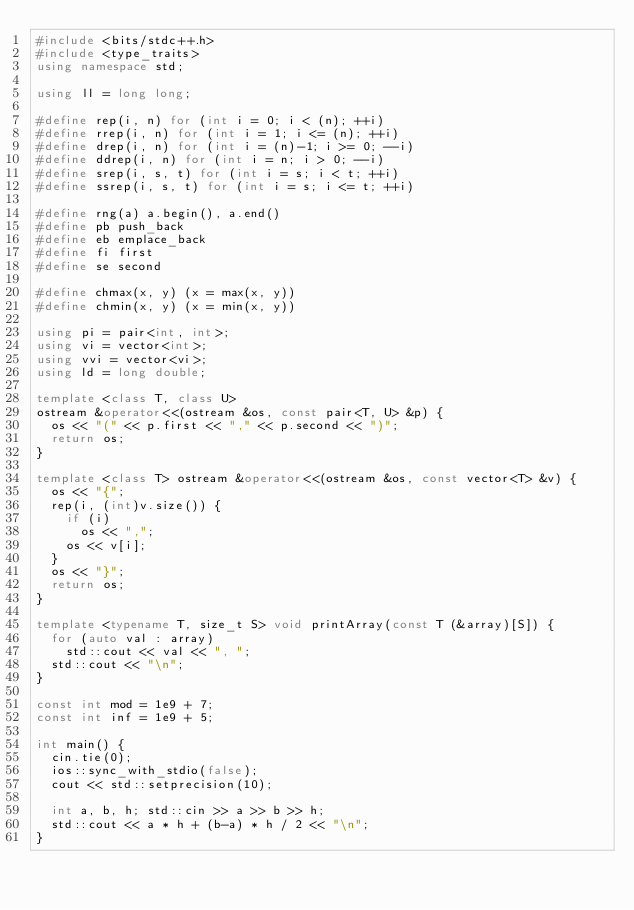<code> <loc_0><loc_0><loc_500><loc_500><_C++_>#include <bits/stdc++.h>
#include <type_traits>
using namespace std;

using ll = long long;

#define rep(i, n) for (int i = 0; i < (n); ++i)
#define rrep(i, n) for (int i = 1; i <= (n); ++i)
#define drep(i, n) for (int i = (n)-1; i >= 0; --i)
#define ddrep(i, n) for (int i = n; i > 0; --i)
#define srep(i, s, t) for (int i = s; i < t; ++i)
#define ssrep(i, s, t) for (int i = s; i <= t; ++i)

#define rng(a) a.begin(), a.end()
#define pb push_back
#define eb emplace_back
#define fi first
#define se second

#define chmax(x, y) (x = max(x, y))
#define chmin(x, y) (x = min(x, y))

using pi = pair<int, int>;
using vi = vector<int>;
using vvi = vector<vi>;
using ld = long double;

template <class T, class U>
ostream &operator<<(ostream &os, const pair<T, U> &p) {
  os << "(" << p.first << "," << p.second << ")";
  return os;
}

template <class T> ostream &operator<<(ostream &os, const vector<T> &v) {
  os << "{";
  rep(i, (int)v.size()) {
    if (i)
      os << ",";
    os << v[i];
  }
  os << "}";
  return os;
}

template <typename T, size_t S> void printArray(const T (&array)[S]) {
  for (auto val : array)
    std::cout << val << ", ";
  std::cout << "\n";
}

const int mod = 1e9 + 7;
const int inf = 1e9 + 5;

int main() {
  cin.tie(0);
  ios::sync_with_stdio(false);
  cout << std::setprecision(10);

  int a, b, h; std::cin >> a >> b >> h;
  std::cout << a * h + (b-a) * h / 2 << "\n";
}
</code> 